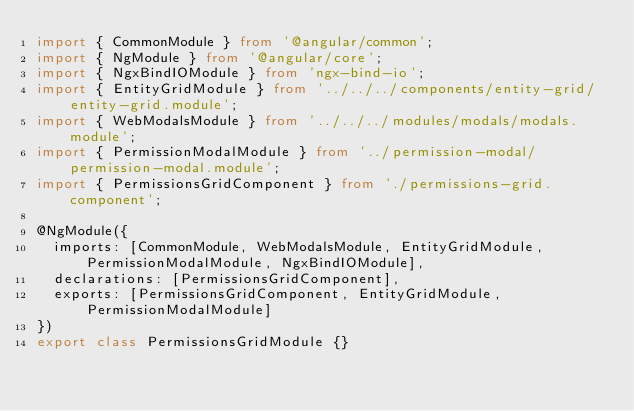<code> <loc_0><loc_0><loc_500><loc_500><_TypeScript_>import { CommonModule } from '@angular/common';
import { NgModule } from '@angular/core';
import { NgxBindIOModule } from 'ngx-bind-io';
import { EntityGridModule } from '../../../components/entity-grid/entity-grid.module';
import { WebModalsModule } from '../../../modules/modals/modals.module';
import { PermissionModalModule } from '../permission-modal/permission-modal.module';
import { PermissionsGridComponent } from './permissions-grid.component';

@NgModule({
  imports: [CommonModule, WebModalsModule, EntityGridModule, PermissionModalModule, NgxBindIOModule],
  declarations: [PermissionsGridComponent],
  exports: [PermissionsGridComponent, EntityGridModule, PermissionModalModule]
})
export class PermissionsGridModule {}
</code> 